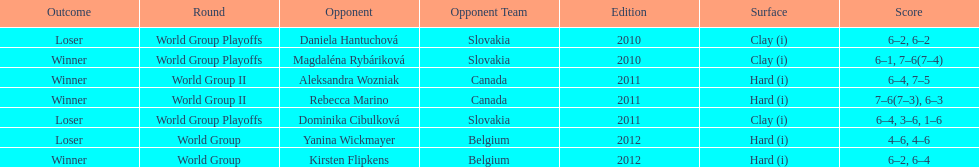What was the next game listed after the world group ii rounds? World Group Playoffs. 